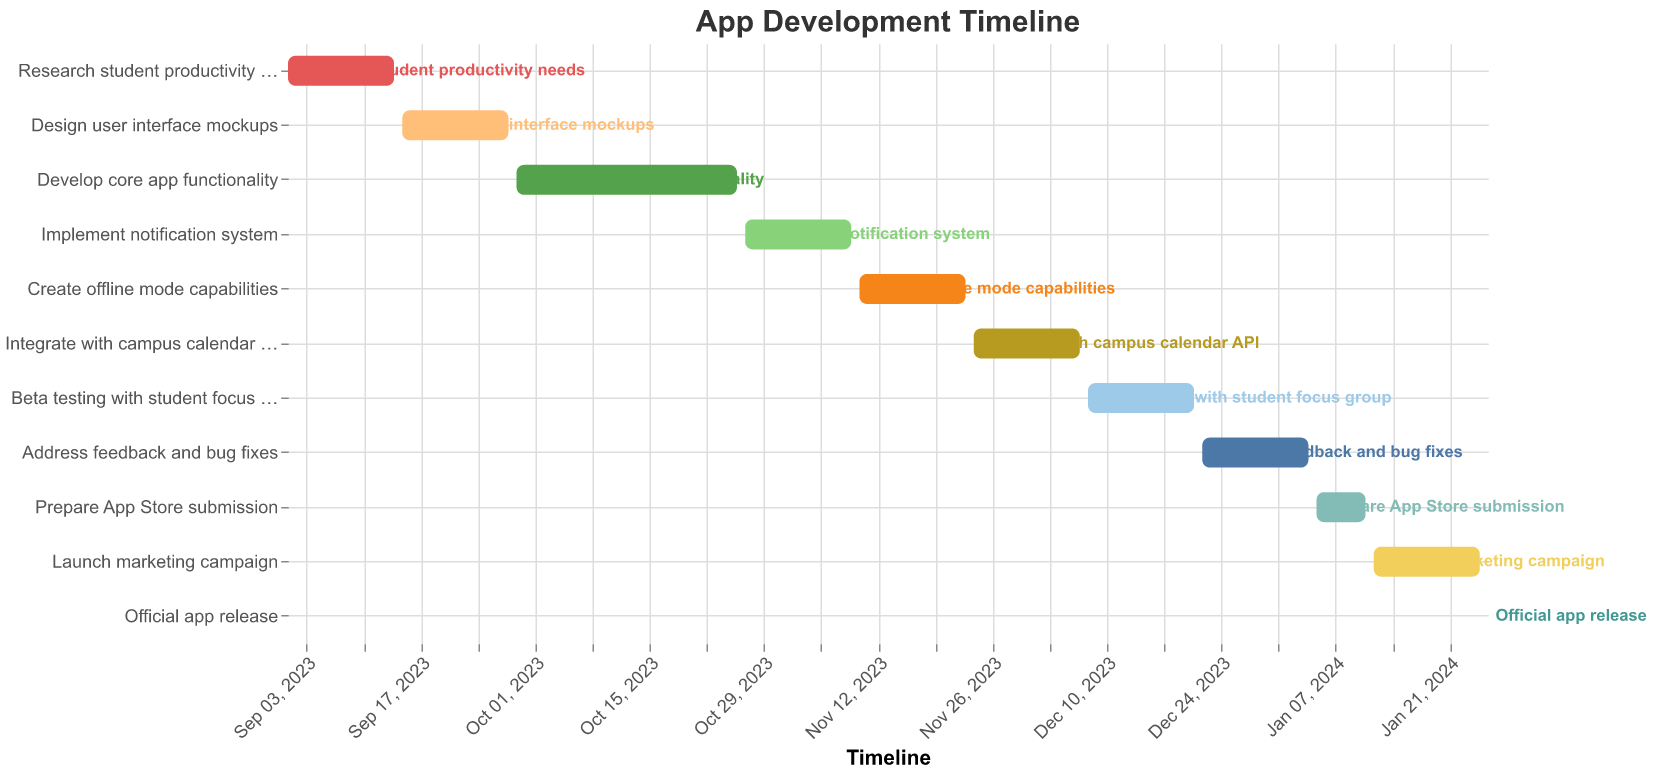What is the title of the Gantt Chart? The title is generally located at the top of the Gantt Chart and provides an overview of what the chart represents. In this case, the title is clearly mentioned as "App Development Timeline".
Answer: App Development Timeline How long is the "Develop core app functionality" phase? To find the length of the "Develop core app functionality" phase, we can look at the "Duration" column in the data. The duration is given in days.
Answer: 28 days When does the "Beta testing with student focus group" phase start? The starting date for this phase is found by looking at the "Start Date" column next to the "Beta testing with student focus group" task in the data.
Answer: December 8, 2023 Which phase has the shortest duration? By examining the "Duration" column across all tasks, the phase with the shortest duration can be identified as the one with the lowest number of days. This task is "Official app release" which takes 1 day.
Answer: Official app release What is the total length of time from the beginning of the "Research student productivity needs" phase to the end of the "Official app release" phase? To determine the total length of time, we note that the "Research student productivity needs" phase starts on September 1, 2023, and the "Official app release" ends on January 26, 2024. Counting the days between these two dates gives the total time span in days.
Answer: 148 days What phases overlap in the timeline? To answer this, we need to carefully observe the start and end dates of each phase and see which phases have overlapping dates. For example, "Beta testing with student focus group" overlaps with "Address feedback and bug fixes" because their timeline dates intersect.
Answer: Multiple phases overlap, including "Beta testing with student focus group" and "Address feedback and bug fixes" Which phase ends right before "Create offline mode capabilities" begins? To find this, we need to look at the end dates of all phases and identify which phase ends on the day before the start date of "Create offline mode capabilities", which starts on November 10, 2023. The preceding phase is "Implement notification system" which ends on November 9, 2023.
Answer: Implement notification system How many phases have a duration of 14 days? By counting all occurrences of the number 14 in the "Duration" column, we can tally up the number of phases that each has a duration of 14 days.
Answer: 7 phases 